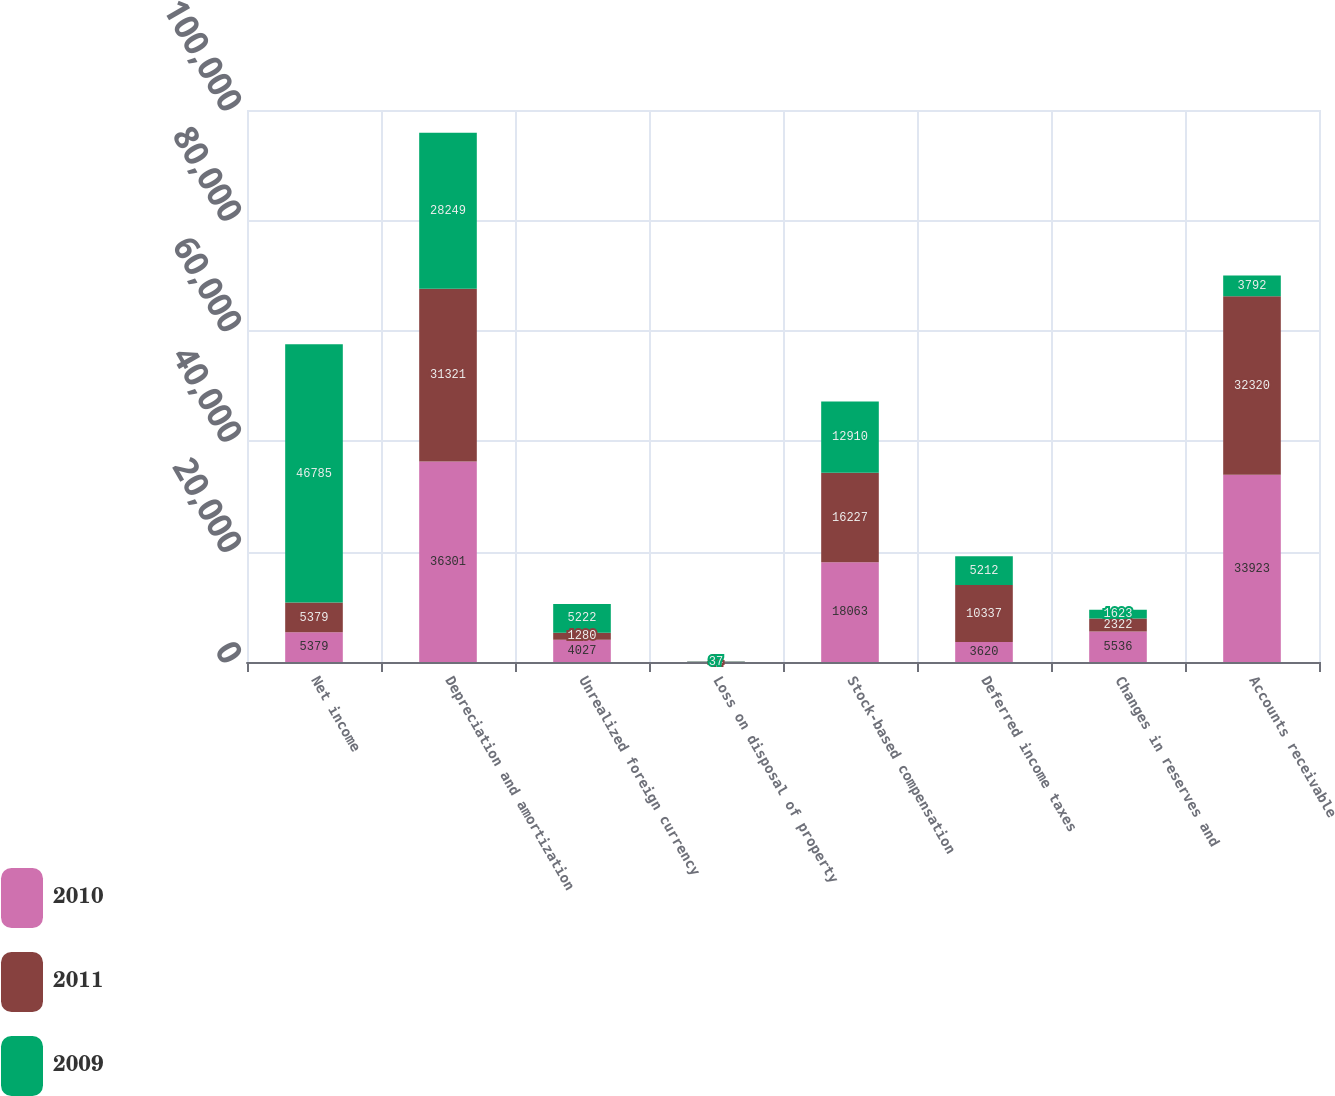Convert chart to OTSL. <chart><loc_0><loc_0><loc_500><loc_500><stacked_bar_chart><ecel><fcel>Net income<fcel>Depreciation and amortization<fcel>Unrealized foreign currency<fcel>Loss on disposal of property<fcel>Stock-based compensation<fcel>Deferred income taxes<fcel>Changes in reserves and<fcel>Accounts receivable<nl><fcel>2010<fcel>5379<fcel>36301<fcel>4027<fcel>36<fcel>18063<fcel>3620<fcel>5536<fcel>33923<nl><fcel>2011<fcel>5379<fcel>31321<fcel>1280<fcel>44<fcel>16227<fcel>10337<fcel>2322<fcel>32320<nl><fcel>2009<fcel>46785<fcel>28249<fcel>5222<fcel>37<fcel>12910<fcel>5212<fcel>1623<fcel>3792<nl></chart> 